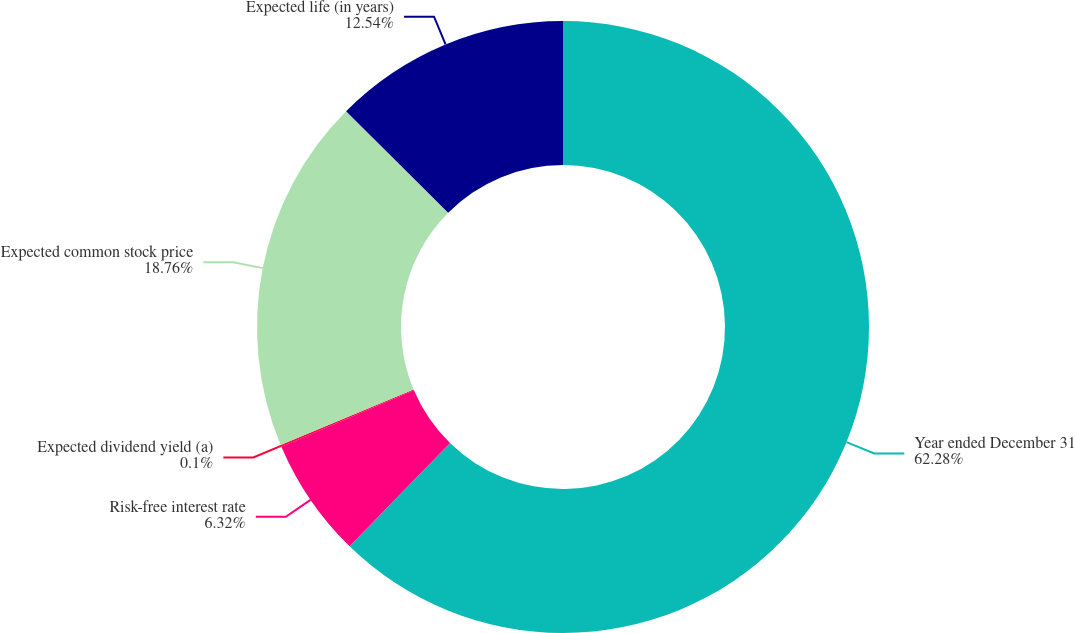Convert chart to OTSL. <chart><loc_0><loc_0><loc_500><loc_500><pie_chart><fcel>Year ended December 31<fcel>Risk-free interest rate<fcel>Expected dividend yield (a)<fcel>Expected common stock price<fcel>Expected life (in years)<nl><fcel>62.29%<fcel>6.32%<fcel>0.1%<fcel>18.76%<fcel>12.54%<nl></chart> 